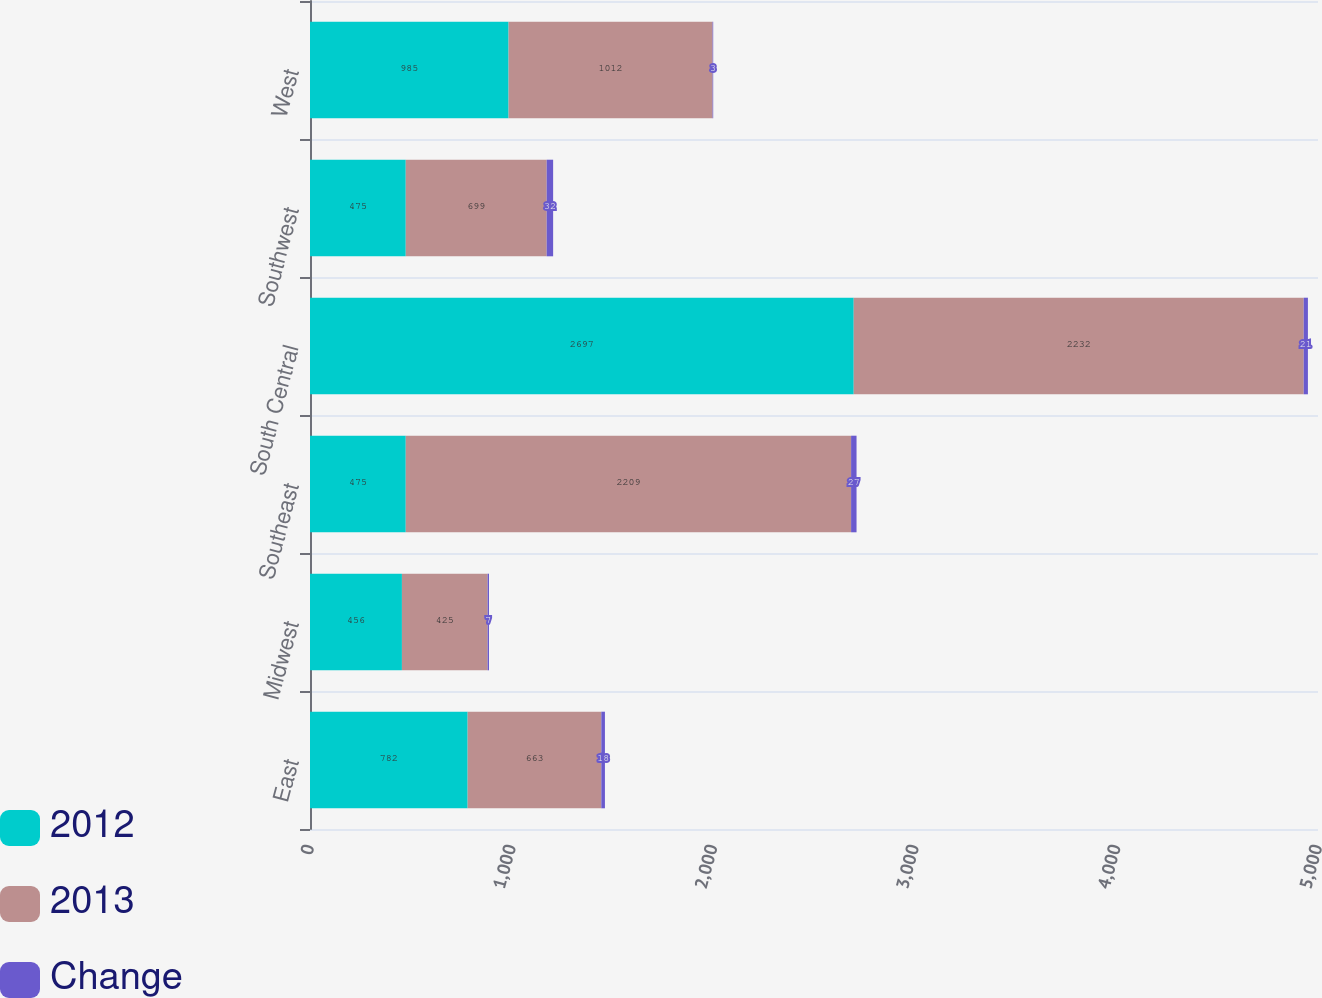Convert chart. <chart><loc_0><loc_0><loc_500><loc_500><stacked_bar_chart><ecel><fcel>East<fcel>Midwest<fcel>Southeast<fcel>South Central<fcel>Southwest<fcel>West<nl><fcel>2012<fcel>782<fcel>456<fcel>475<fcel>2697<fcel>475<fcel>985<nl><fcel>2013<fcel>663<fcel>425<fcel>2209<fcel>2232<fcel>699<fcel>1012<nl><fcel>Change<fcel>18<fcel>7<fcel>27<fcel>21<fcel>32<fcel>3<nl></chart> 